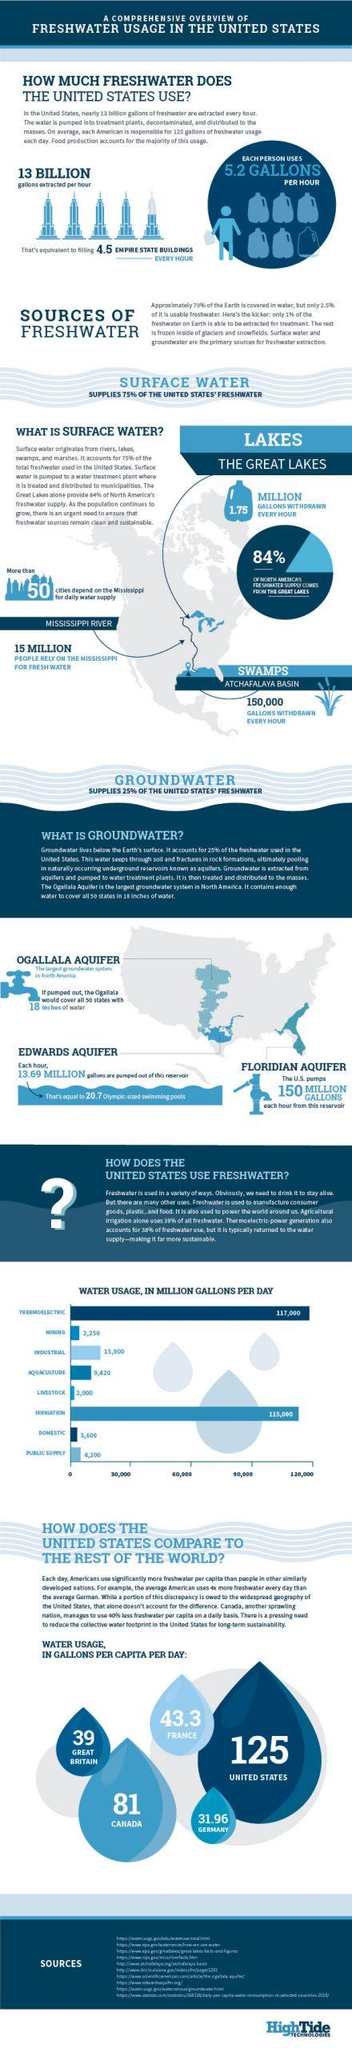List a handful of essential elements in this visual. The Great Lakes provide approximately 84% of the fresh water supply in North America. In the United States, fresh water is mainly used for thermoelectric purposes on a daily basis. Seventy-five percent of the United States' fresh water supply comes from surface water. Every hour, approximately 150,000 gallons of water are withdrawn from the swamps of the Atchafalaya Basin. In the United States, approximately 50 cities rely on the Mississippi River for their daily water supply. 